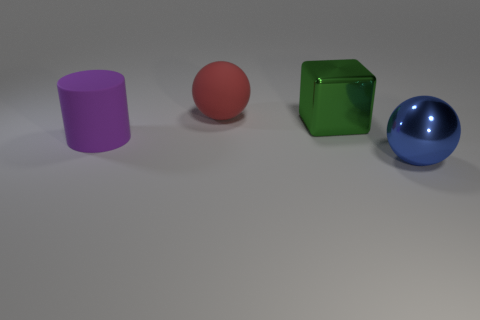There is a rubber object in front of the ball to the left of the big green metal cube; how many things are right of it?
Provide a short and direct response. 3. How many objects are behind the big cylinder and in front of the big matte ball?
Make the answer very short. 1. Is there anything else that has the same color as the block?
Your response must be concise. No. How many rubber objects are either big purple objects or tiny brown blocks?
Ensure brevity in your answer.  1. The object in front of the big rubber thing that is to the left of the big ball on the left side of the green object is made of what material?
Offer a very short reply. Metal. The large sphere behind the large matte object that is in front of the big red rubber sphere is made of what material?
Your response must be concise. Rubber. Is the size of the metal thing in front of the purple cylinder the same as the object that is behind the large metal cube?
Keep it short and to the point. Yes. What number of small objects are either shiny spheres or green metal objects?
Make the answer very short. 0. What number of objects are either objects to the right of the red rubber object or big purple rubber cylinders?
Provide a succinct answer. 3. What number of other things are there of the same shape as the green metallic thing?
Keep it short and to the point. 0. 